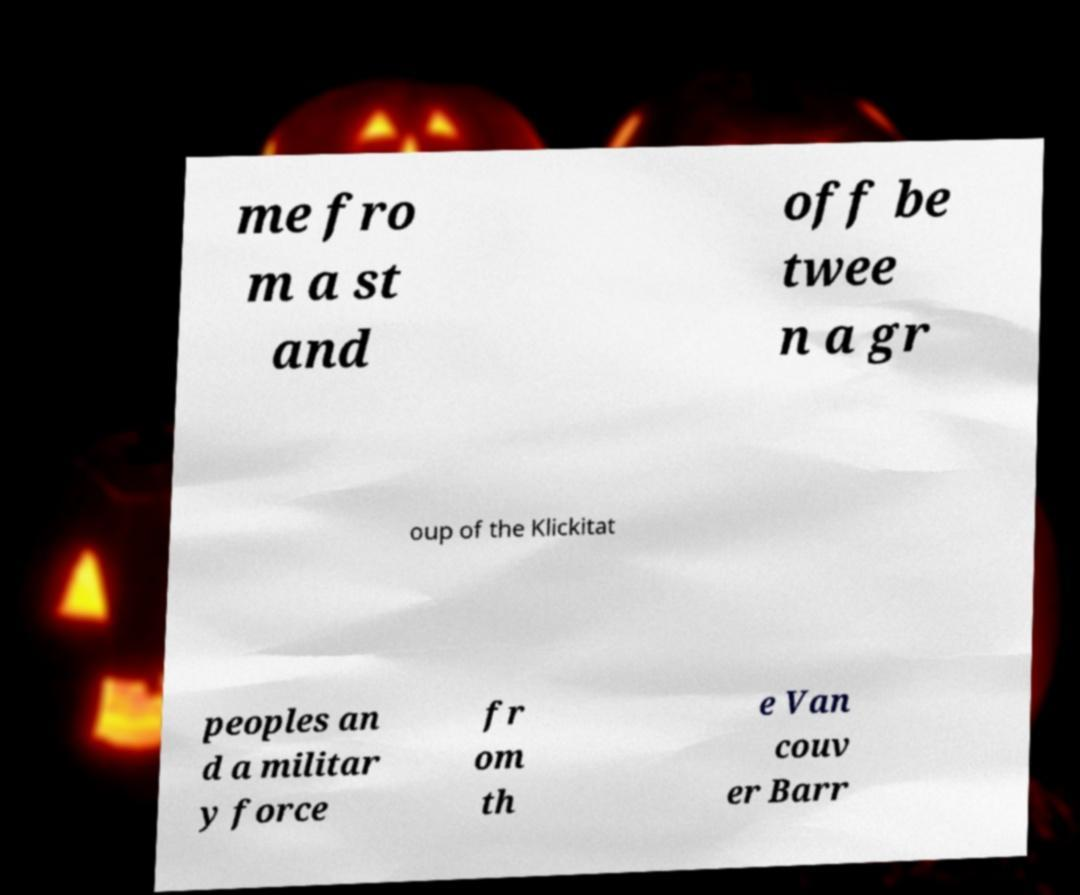Please identify and transcribe the text found in this image. me fro m a st and off be twee n a gr oup of the Klickitat peoples an d a militar y force fr om th e Van couv er Barr 